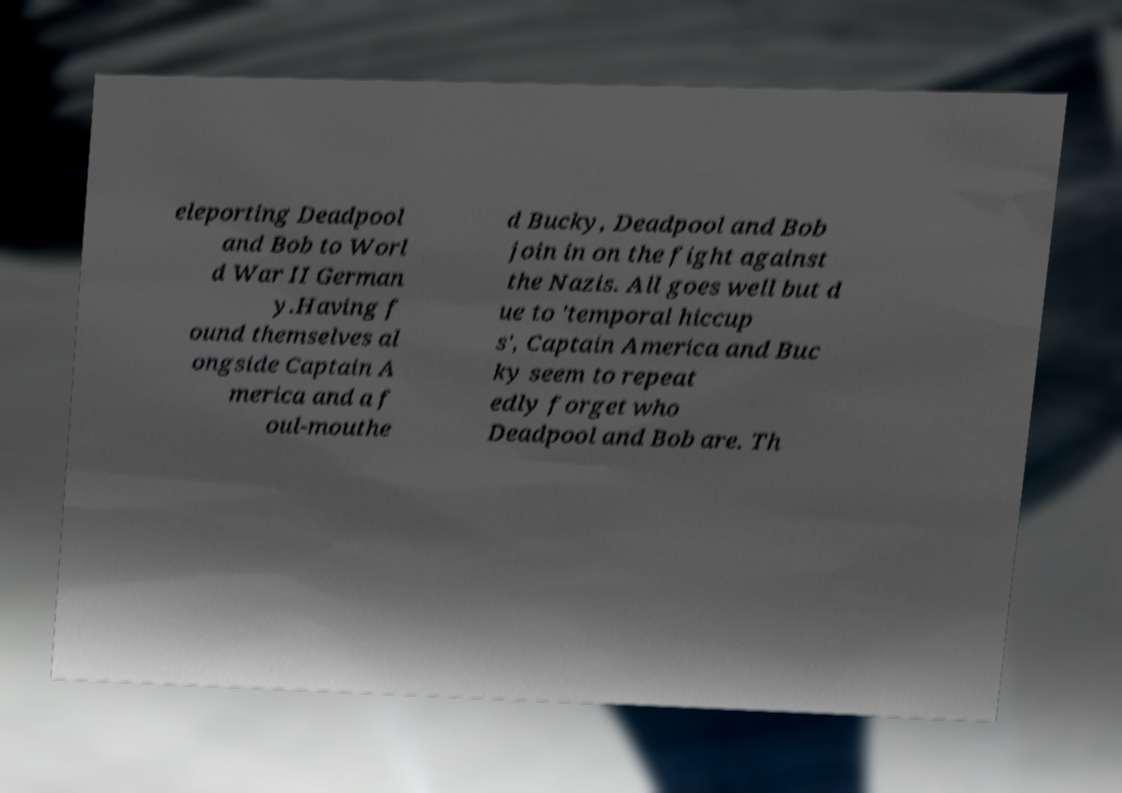I need the written content from this picture converted into text. Can you do that? eleporting Deadpool and Bob to Worl d War II German y.Having f ound themselves al ongside Captain A merica and a f oul-mouthe d Bucky, Deadpool and Bob join in on the fight against the Nazis. All goes well but d ue to 'temporal hiccup s', Captain America and Buc ky seem to repeat edly forget who Deadpool and Bob are. Th 